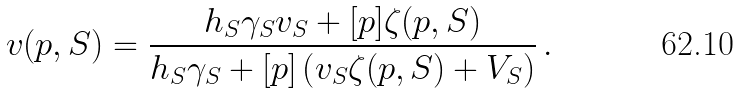<formula> <loc_0><loc_0><loc_500><loc_500>v ( p , S ) = \frac { h _ { S } \gamma _ { S } v _ { S } + [ p ] \zeta ( p , S ) } { h _ { S } \gamma _ { S } + [ p ] \left ( v _ { S } \zeta ( p , S ) + V _ { S } \right ) } \, .</formula> 